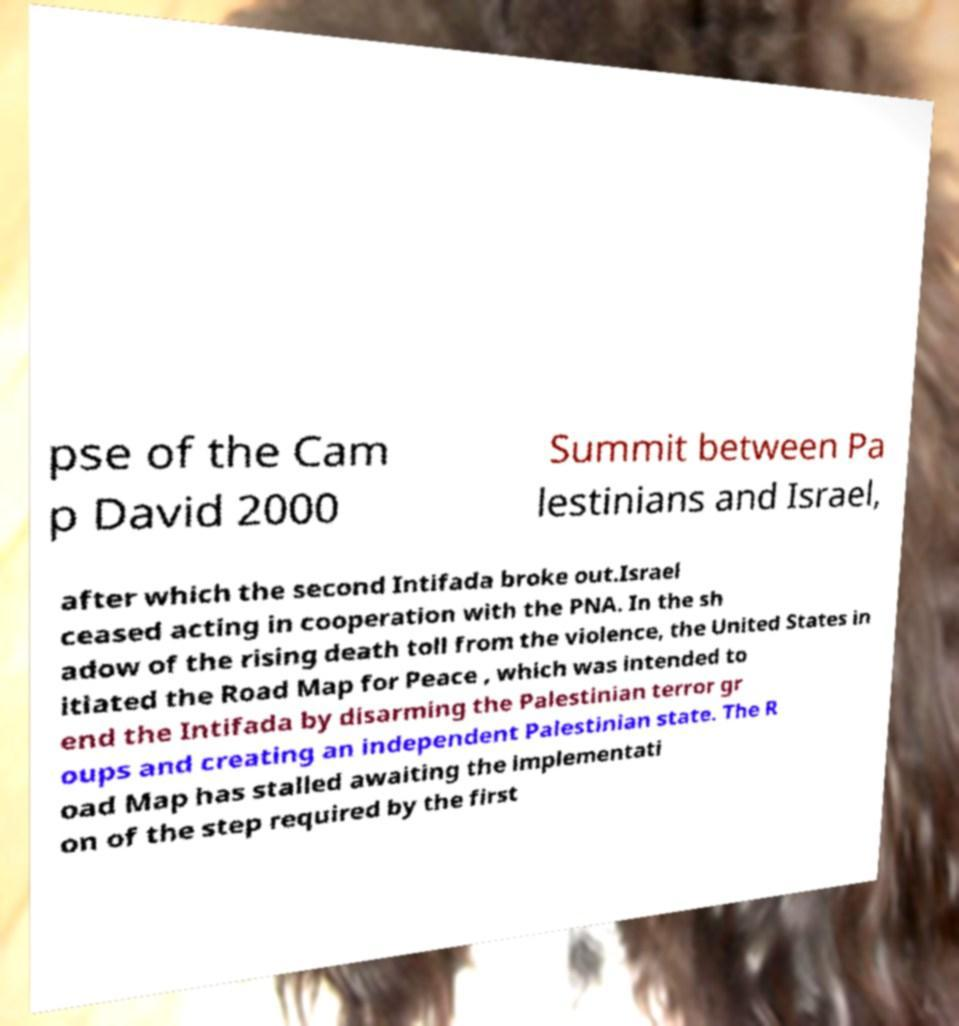Can you accurately transcribe the text from the provided image for me? pse of the Cam p David 2000 Summit between Pa lestinians and Israel, after which the second Intifada broke out.Israel ceased acting in cooperation with the PNA. In the sh adow of the rising death toll from the violence, the United States in itiated the Road Map for Peace , which was intended to end the Intifada by disarming the Palestinian terror gr oups and creating an independent Palestinian state. The R oad Map has stalled awaiting the implementati on of the step required by the first 